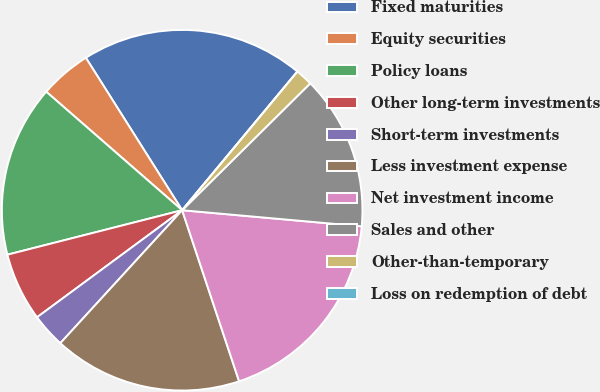Convert chart to OTSL. <chart><loc_0><loc_0><loc_500><loc_500><pie_chart><fcel>Fixed maturities<fcel>Equity securities<fcel>Policy loans<fcel>Other long-term investments<fcel>Short-term investments<fcel>Less investment expense<fcel>Net investment income<fcel>Sales and other<fcel>Other-than-temporary<fcel>Loss on redemption of debt<nl><fcel>20.0%<fcel>4.62%<fcel>15.38%<fcel>6.15%<fcel>3.08%<fcel>16.92%<fcel>18.46%<fcel>13.85%<fcel>1.54%<fcel>0.0%<nl></chart> 